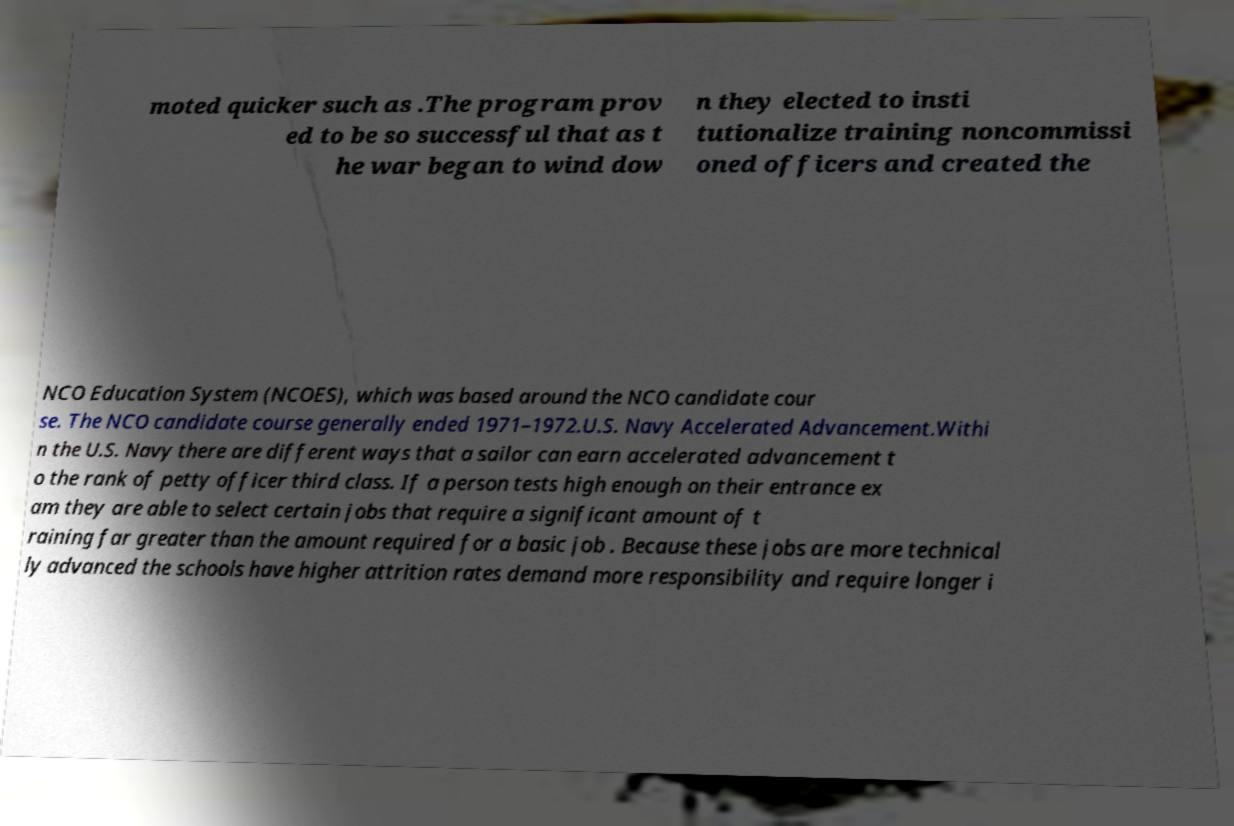What messages or text are displayed in this image? I need them in a readable, typed format. moted quicker such as .The program prov ed to be so successful that as t he war began to wind dow n they elected to insti tutionalize training noncommissi oned officers and created the NCO Education System (NCOES), which was based around the NCO candidate cour se. The NCO candidate course generally ended 1971–1972.U.S. Navy Accelerated Advancement.Withi n the U.S. Navy there are different ways that a sailor can earn accelerated advancement t o the rank of petty officer third class. If a person tests high enough on their entrance ex am they are able to select certain jobs that require a significant amount of t raining far greater than the amount required for a basic job . Because these jobs are more technical ly advanced the schools have higher attrition rates demand more responsibility and require longer i 